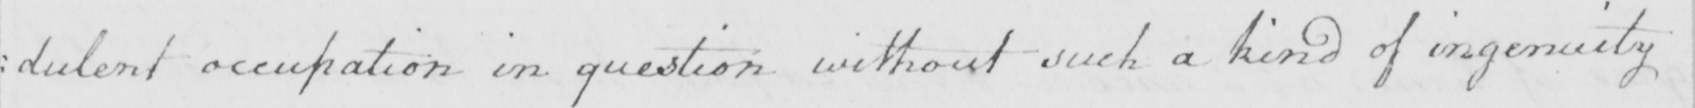What is written in this line of handwriting? : dulent occupation in question without such a kind of ingenuity 